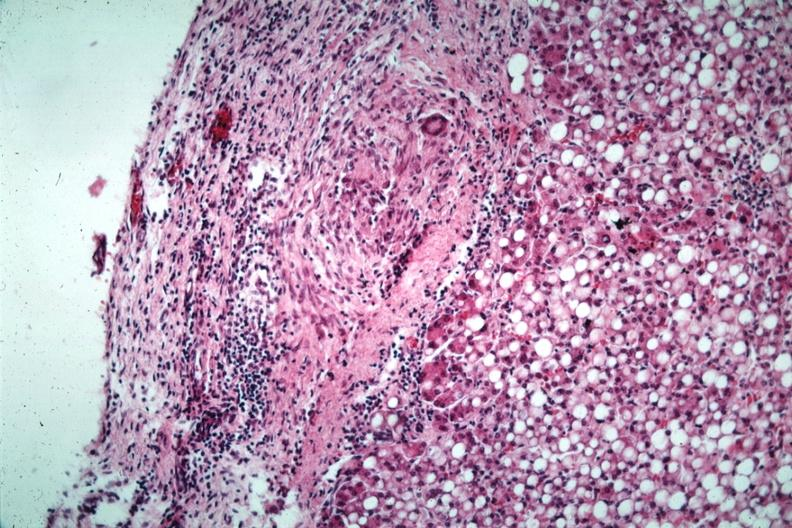what is present?
Answer the question using a single word or phrase. Abdomen 